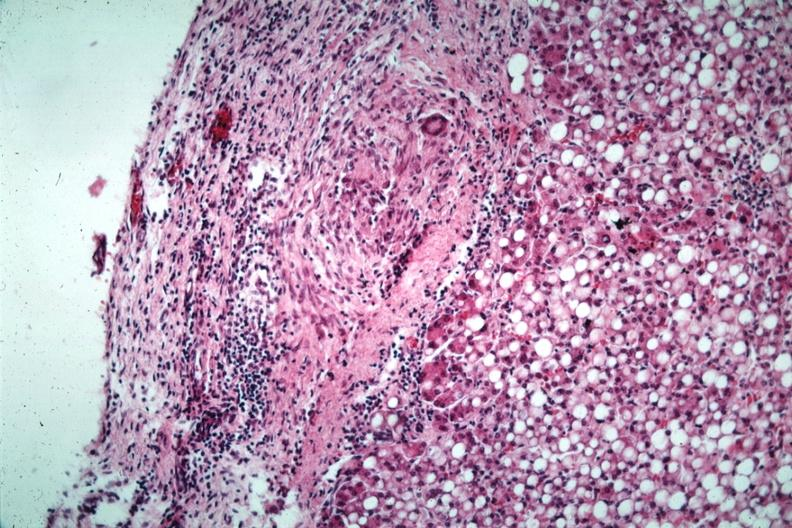what is present?
Answer the question using a single word or phrase. Abdomen 